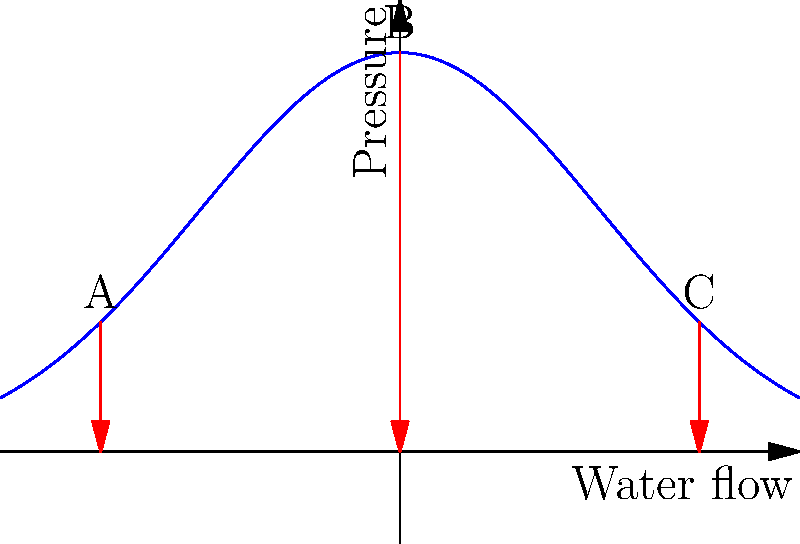In the diagram above, which represents the pressure distribution around an octopus during jet propulsion, at which point is the pressure difference most significant, contributing to the greatest thrust? To determine the point of greatest thrust during octopus jet propulsion, we need to analyze the pressure distribution shown in the graph:

1. The x-axis represents water flow, and the y-axis represents pressure.
2. The blue curve shows the pressure distribution around the octopus during jet propulsion.
3. Three points are labeled: A, B, and C.
4. The red arrows indicate the pressure difference at each point.

To find the point of greatest thrust:

1. Observe that thrust is generated by pressure differences.
2. A larger pressure difference (longer red arrow) indicates greater thrust.
3. Compare the lengths of the red arrows at points A, B, and C:
   - Point A: Moderate arrow length
   - Point B: Longest arrow
   - Point C: Shortest arrow

4. The longest red arrow corresponds to the greatest pressure difference.
5. The greatest pressure difference contributes to the most significant thrust.

Therefore, point B, located at the peak of the pressure curve, represents the area where the pressure difference is most significant, contributing to the greatest thrust during octopus jet propulsion.
Answer: B 